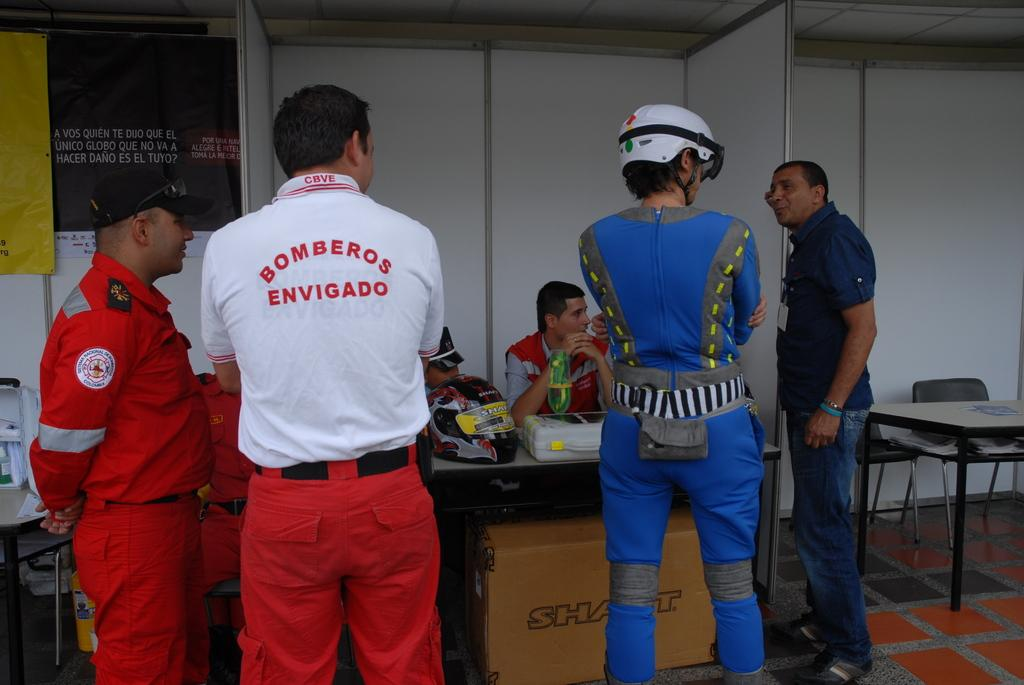<image>
Present a compact description of the photo's key features. Three man in a huddle, one of them wearing a Bomberos Envigado shirt. 